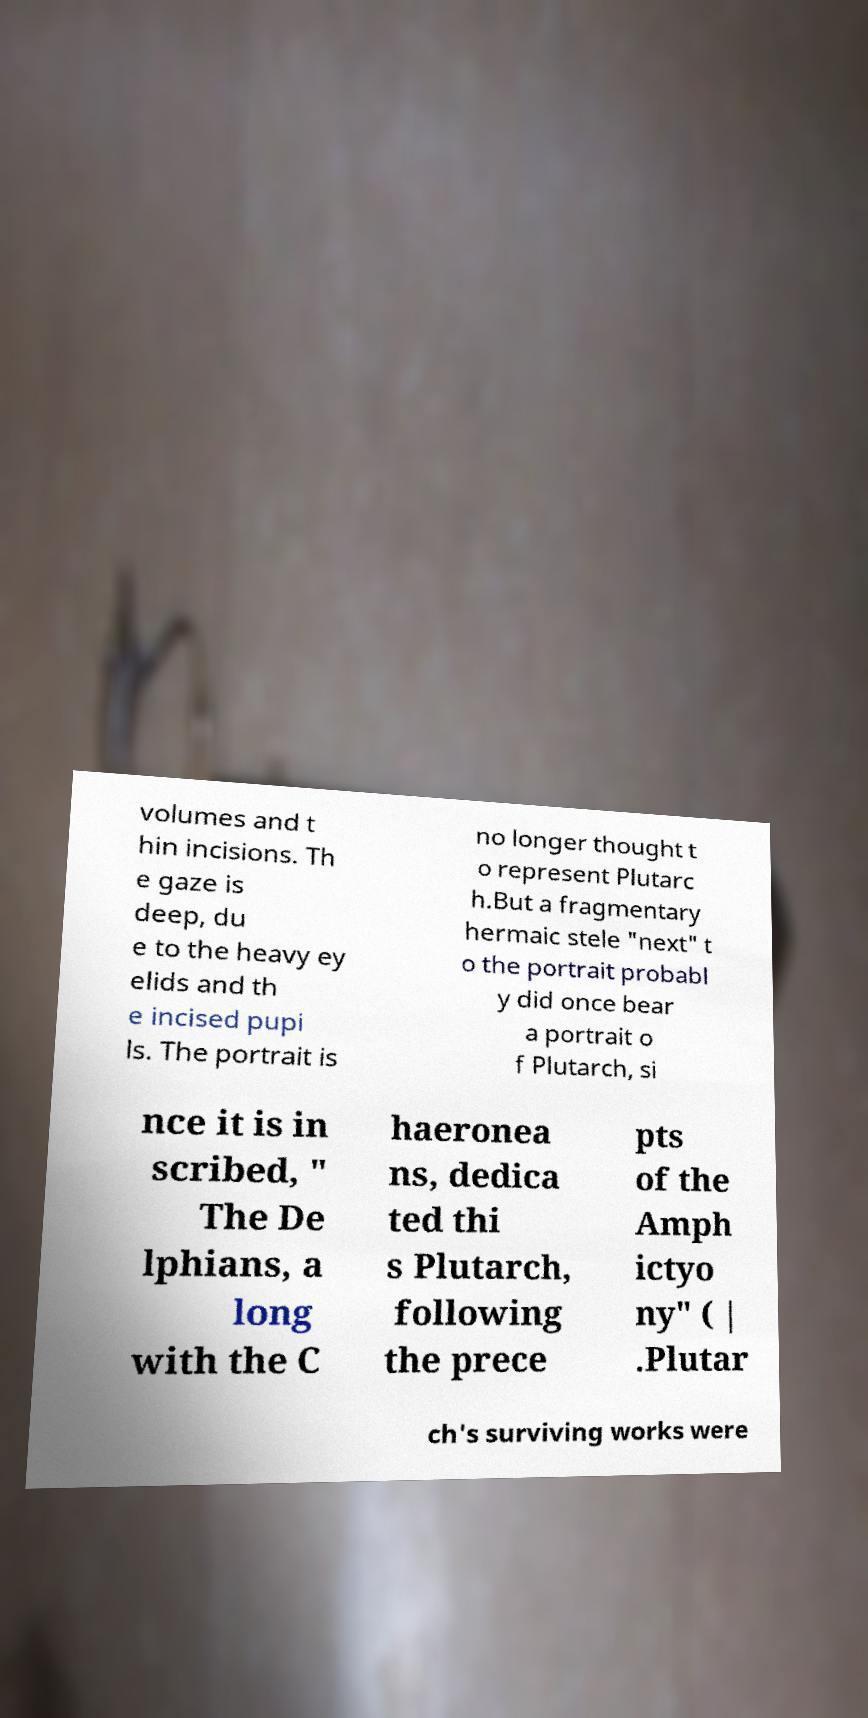Can you accurately transcribe the text from the provided image for me? volumes and t hin incisions. Th e gaze is deep, du e to the heavy ey elids and th e incised pupi ls. The portrait is no longer thought t o represent Plutarc h.But a fragmentary hermaic stele "next" t o the portrait probabl y did once bear a portrait o f Plutarch, si nce it is in scribed, " The De lphians, a long with the C haeronea ns, dedica ted thi s Plutarch, following the prece pts of the Amph ictyo ny" ( | .Plutar ch's surviving works were 